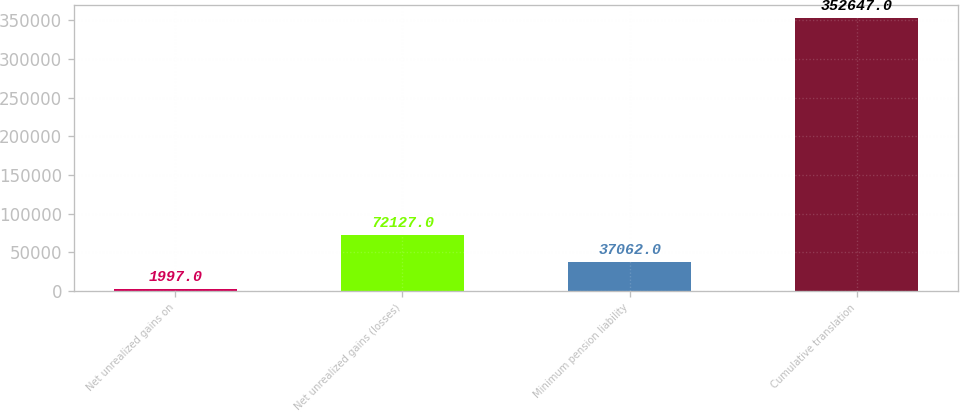<chart> <loc_0><loc_0><loc_500><loc_500><bar_chart><fcel>Net unrealized gains on<fcel>Net unrealized gains (losses)<fcel>Minimum pension liability<fcel>Cumulative translation<nl><fcel>1997<fcel>72127<fcel>37062<fcel>352647<nl></chart> 